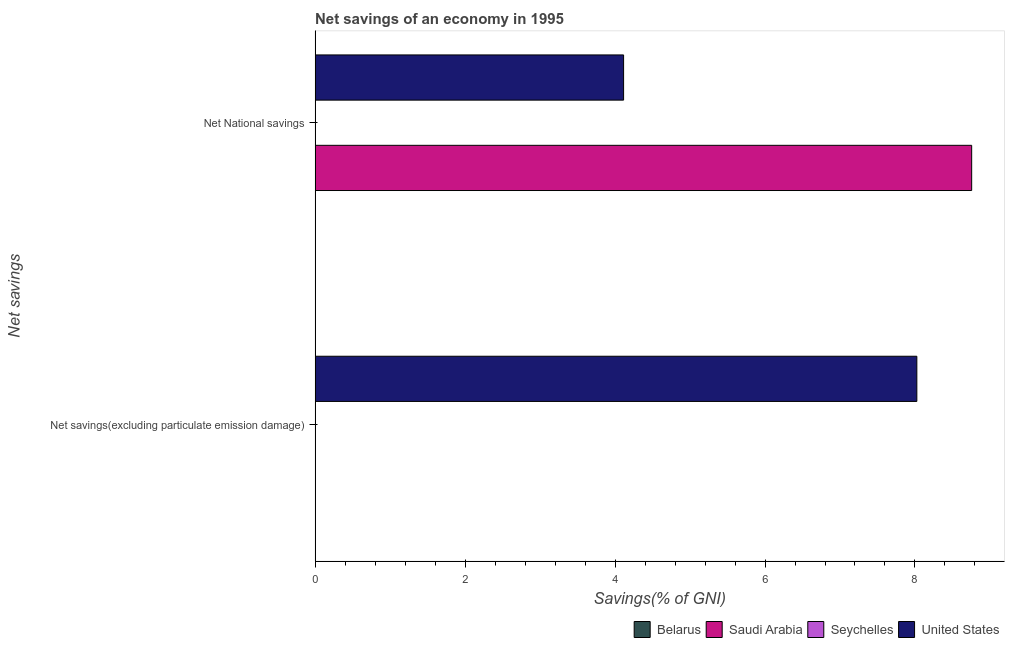Are the number of bars on each tick of the Y-axis equal?
Offer a very short reply. No. How many bars are there on the 1st tick from the top?
Your answer should be compact. 2. What is the label of the 1st group of bars from the top?
Ensure brevity in your answer.  Net National savings. What is the net savings(excluding particulate emission damage) in Belarus?
Your response must be concise. 0. Across all countries, what is the maximum net savings(excluding particulate emission damage)?
Offer a very short reply. 8.02. Across all countries, what is the minimum net national savings?
Provide a short and direct response. 0. In which country was the net national savings maximum?
Your answer should be compact. Saudi Arabia. What is the total net national savings in the graph?
Offer a terse response. 12.87. What is the difference between the net national savings in Saudi Arabia and that in United States?
Offer a terse response. 4.64. What is the average net national savings per country?
Offer a very short reply. 3.22. What is the difference between the net national savings and net savings(excluding particulate emission damage) in United States?
Ensure brevity in your answer.  -3.91. In how many countries, is the net national savings greater than 1.6 %?
Your answer should be very brief. 2. Is the net national savings in United States less than that in Saudi Arabia?
Ensure brevity in your answer.  Yes. In how many countries, is the net savings(excluding particulate emission damage) greater than the average net savings(excluding particulate emission damage) taken over all countries?
Ensure brevity in your answer.  1. Are all the bars in the graph horizontal?
Your answer should be compact. Yes. How many countries are there in the graph?
Provide a short and direct response. 4. What is the difference between two consecutive major ticks on the X-axis?
Provide a short and direct response. 2. Are the values on the major ticks of X-axis written in scientific E-notation?
Your answer should be very brief. No. Does the graph contain grids?
Make the answer very short. No. Where does the legend appear in the graph?
Your response must be concise. Bottom right. How many legend labels are there?
Ensure brevity in your answer.  4. What is the title of the graph?
Offer a terse response. Net savings of an economy in 1995. What is the label or title of the X-axis?
Your response must be concise. Savings(% of GNI). What is the label or title of the Y-axis?
Offer a very short reply. Net savings. What is the Savings(% of GNI) of Saudi Arabia in Net savings(excluding particulate emission damage)?
Your response must be concise. 0. What is the Savings(% of GNI) of United States in Net savings(excluding particulate emission damage)?
Keep it short and to the point. 8.02. What is the Savings(% of GNI) in Belarus in Net National savings?
Make the answer very short. 0. What is the Savings(% of GNI) in Saudi Arabia in Net National savings?
Give a very brief answer. 8.76. What is the Savings(% of GNI) of United States in Net National savings?
Ensure brevity in your answer.  4.11. Across all Net savings, what is the maximum Savings(% of GNI) of Saudi Arabia?
Keep it short and to the point. 8.76. Across all Net savings, what is the maximum Savings(% of GNI) of United States?
Your response must be concise. 8.02. Across all Net savings, what is the minimum Savings(% of GNI) in United States?
Make the answer very short. 4.11. What is the total Savings(% of GNI) in Saudi Arabia in the graph?
Make the answer very short. 8.76. What is the total Savings(% of GNI) in Seychelles in the graph?
Your response must be concise. 0. What is the total Savings(% of GNI) of United States in the graph?
Provide a succinct answer. 12.14. What is the difference between the Savings(% of GNI) of United States in Net savings(excluding particulate emission damage) and that in Net National savings?
Your response must be concise. 3.91. What is the average Savings(% of GNI) in Saudi Arabia per Net savings?
Provide a succinct answer. 4.38. What is the average Savings(% of GNI) in United States per Net savings?
Give a very brief answer. 6.07. What is the difference between the Savings(% of GNI) of Saudi Arabia and Savings(% of GNI) of United States in Net National savings?
Your response must be concise. 4.64. What is the ratio of the Savings(% of GNI) in United States in Net savings(excluding particulate emission damage) to that in Net National savings?
Provide a succinct answer. 1.95. What is the difference between the highest and the second highest Savings(% of GNI) in United States?
Your response must be concise. 3.91. What is the difference between the highest and the lowest Savings(% of GNI) in Saudi Arabia?
Your answer should be compact. 8.76. What is the difference between the highest and the lowest Savings(% of GNI) in United States?
Offer a very short reply. 3.91. 